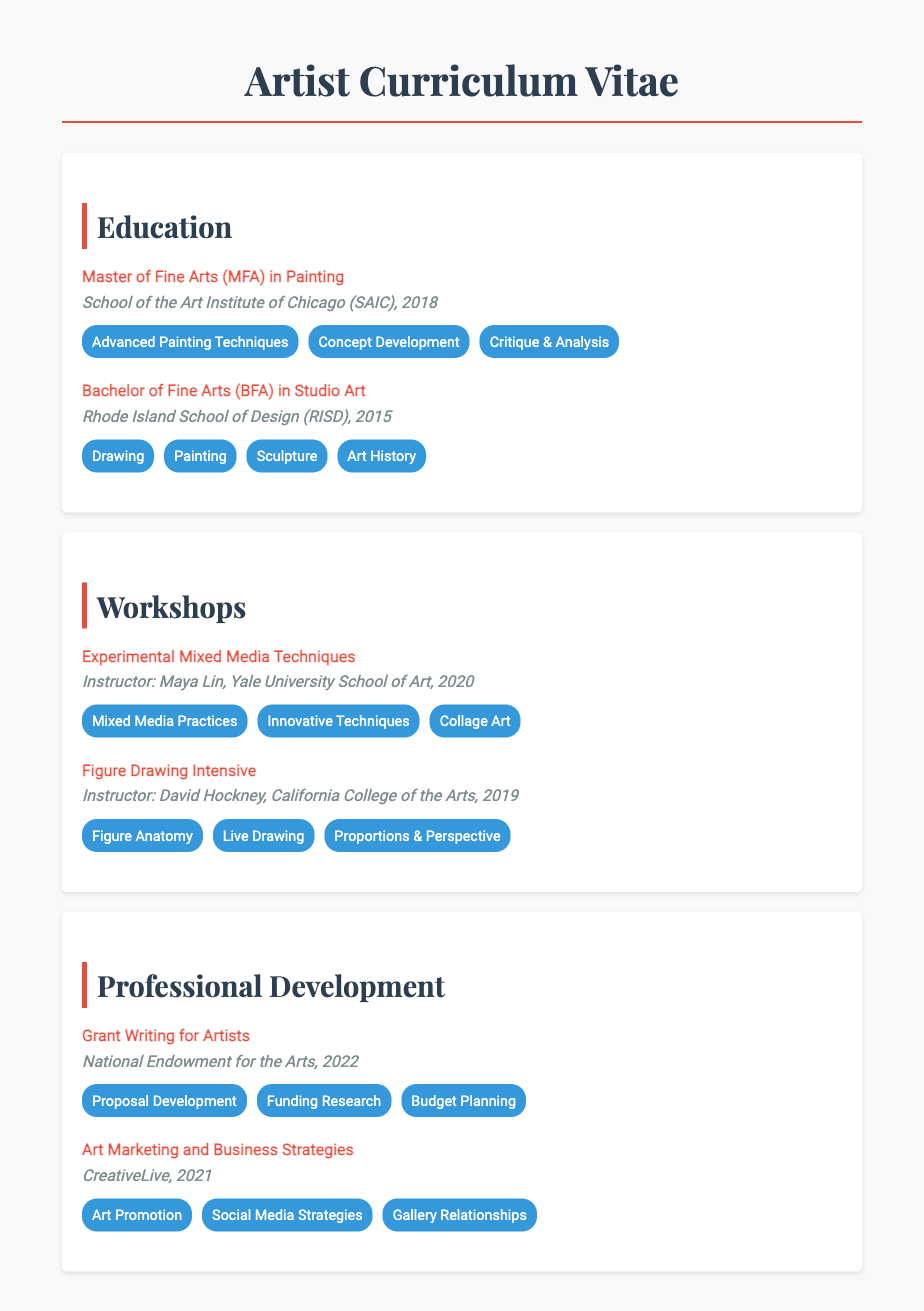What is the highest degree obtained by the artist? The document lists the artist's educational background, indicating the highest degree as the Master of Fine Arts in Painting.
Answer: Master of Fine Arts (MFA) What school awarded the Bachelor's degree? The Bachelor of Fine Arts degree was obtained from the Rhode Island School of Design mentioned in the document.
Answer: Rhode Island School of Design (RISD) In what year did the artist complete their MFA? The document states that the artist completed their MFA in 2018.
Answer: 2018 Who was the instructor for the Experimental Mixed Media Techniques workshop? The document specifies Maya Lin as the instructor for that workshop.
Answer: Maya Lin What key skill was acquired during the Figure Drawing Intensive? According to the document, Figure Anatomy is one of the skills learned during this intensive workshop.
Answer: Figure Anatomy How many workshops are listed in the document? The document provides information about two specific workshops attended by the artist.
Answer: 2 Which organization offered the Grant Writing for Artists course? The National Endowment for the Arts is mentioned in the document as the offering organization for this course.
Answer: National Endowment for the Arts What year did the artist attend the Art Marketing and Business Strategies course? The document indicates this professional development course was attended in 2021.
Answer: 2021 List one of the skills acquired from the Bachelor of Fine Arts program. The document highlights several skills, one of which is Drawing.
Answer: Drawing 